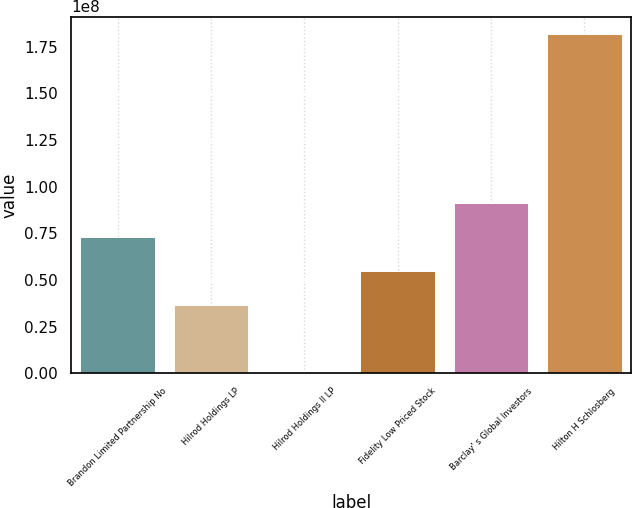Convert chart to OTSL. <chart><loc_0><loc_0><loc_500><loc_500><bar_chart><fcel>Brandon Limited Partnership No<fcel>Hilrod Holdings LP<fcel>Hilrod Holdings II LP<fcel>Fidelity Low Priced Stock<fcel>Barclay' s Global Investors<fcel>Hilton H Schlosberg<nl><fcel>7.30658e+07<fcel>3.67617e+07<fcel>457552<fcel>5.49137e+07<fcel>9.12178e+07<fcel>1.81978e+08<nl></chart> 